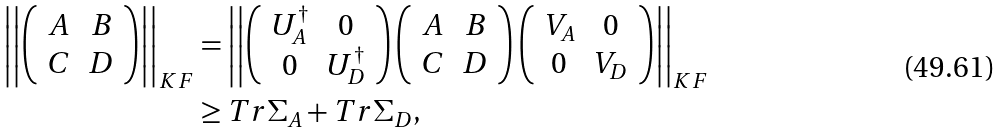Convert formula to latex. <formula><loc_0><loc_0><loc_500><loc_500>\left | \left | \left ( \begin{array} { c c } A & B \\ C & D \\ \end{array} \right ) \right | \right | _ { K F } & = \left | \left | \left ( \begin{array} { c c } U _ { A } ^ { \dag } & 0 \\ 0 & U _ { D } ^ { \dag } \\ \end{array} \right ) \left ( \begin{array} { c c } A & B \\ C & D \\ \end{array} \right ) \left ( \begin{array} { c c } V _ { A } & 0 \\ 0 & V _ { D } \\ \end{array} \right ) \right | \right | _ { K F } \\ & \geq T r \Sigma _ { A } + T r \Sigma _ { D } ,</formula> 